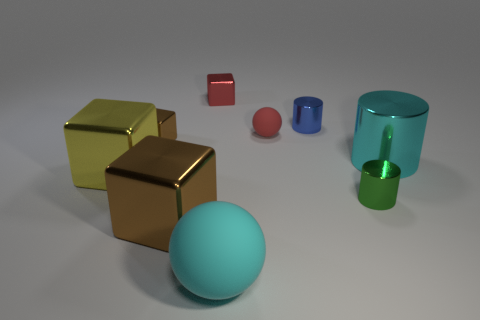Do the cylinder behind the large cyan shiny cylinder and the red cube to the left of the big cyan cylinder have the same size?
Your response must be concise. Yes. What number of objects are yellow blocks or big objects to the left of the tiny brown shiny cube?
Keep it short and to the point. 1. There is a brown thing behind the large yellow metal block; what size is it?
Offer a very short reply. Small. Are there fewer large blocks that are on the right side of the tiny green cylinder than red metal blocks in front of the big cyan metallic cylinder?
Offer a terse response. No. There is a big object that is both behind the green metal object and left of the blue metal object; what material is it?
Provide a succinct answer. Metal. There is a red thing that is to the right of the cube behind the tiny red matte object; what shape is it?
Offer a very short reply. Sphere. Is the big ball the same color as the tiny ball?
Offer a very short reply. No. What number of purple objects are either small metal things or tiny balls?
Offer a terse response. 0. There is a big brown object; are there any small green metal cylinders right of it?
Give a very brief answer. Yes. How big is the yellow object?
Provide a succinct answer. Large. 